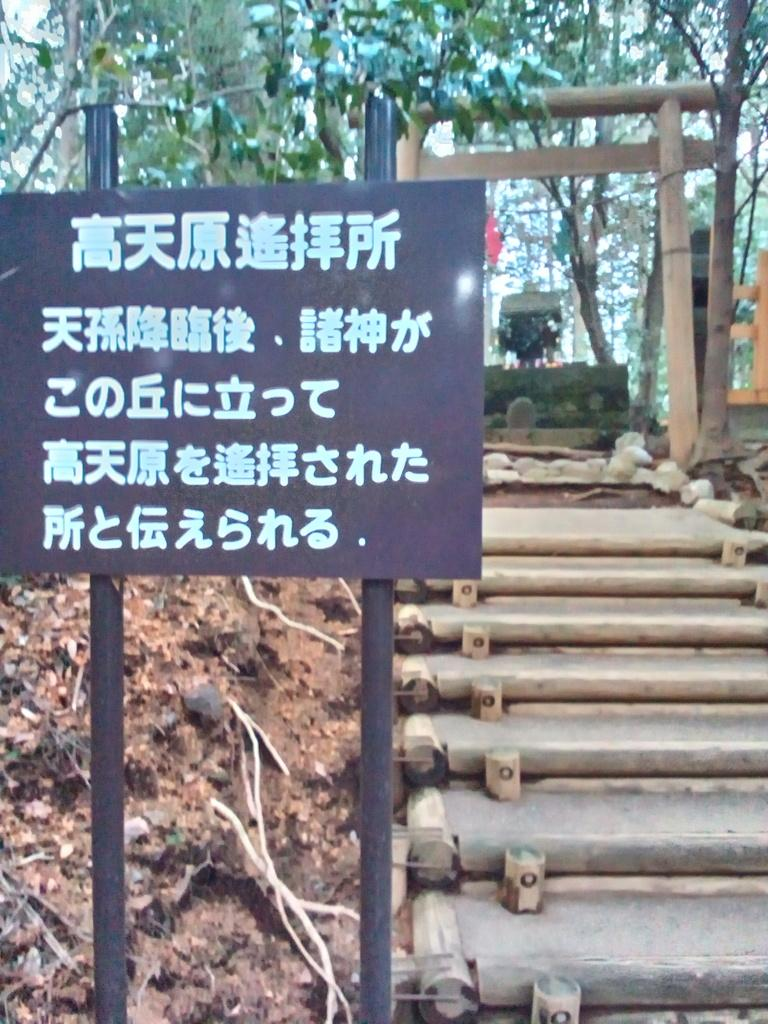What is the dog playing with in the image? The dog is playing with a ball in the image. What color is the dog in the image? The dog is brown in color. Can you describe the dog's activity in the image? The dog is playing with a ball, which suggests it is engaged in a fun and active pursuit. How much does the spot on the dog weigh in the image? There is no spot mentioned in the image, and weight cannot be attributed to a spot. 